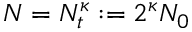Convert formula to latex. <formula><loc_0><loc_0><loc_500><loc_500>N = N _ { t } ^ { \kappa } \colon = 2 ^ { \kappa } N _ { 0 }</formula> 